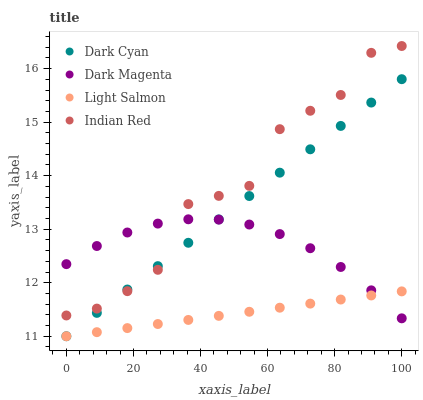Does Light Salmon have the minimum area under the curve?
Answer yes or no. Yes. Does Indian Red have the maximum area under the curve?
Answer yes or no. Yes. Does Dark Magenta have the minimum area under the curve?
Answer yes or no. No. Does Dark Magenta have the maximum area under the curve?
Answer yes or no. No. Is Dark Cyan the smoothest?
Answer yes or no. Yes. Is Indian Red the roughest?
Answer yes or no. Yes. Is Light Salmon the smoothest?
Answer yes or no. No. Is Light Salmon the roughest?
Answer yes or no. No. Does Dark Cyan have the lowest value?
Answer yes or no. Yes. Does Dark Magenta have the lowest value?
Answer yes or no. No. Does Indian Red have the highest value?
Answer yes or no. Yes. Does Dark Magenta have the highest value?
Answer yes or no. No. Is Light Salmon less than Indian Red?
Answer yes or no. Yes. Is Indian Red greater than Light Salmon?
Answer yes or no. Yes. Does Indian Red intersect Dark Magenta?
Answer yes or no. Yes. Is Indian Red less than Dark Magenta?
Answer yes or no. No. Is Indian Red greater than Dark Magenta?
Answer yes or no. No. Does Light Salmon intersect Indian Red?
Answer yes or no. No. 